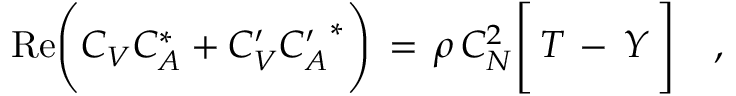<formula> <loc_0><loc_0><loc_500><loc_500>R e \left ( C _ { V } C _ { A } ^ { * } + C _ { V } ^ { \prime } { C _ { A } ^ { \prime } } ^ { * } \right ) \, = \, \rho \, C _ { N } ^ { 2 } \left [ \, T \, - \, Y \, \right ] \quad ,</formula> 